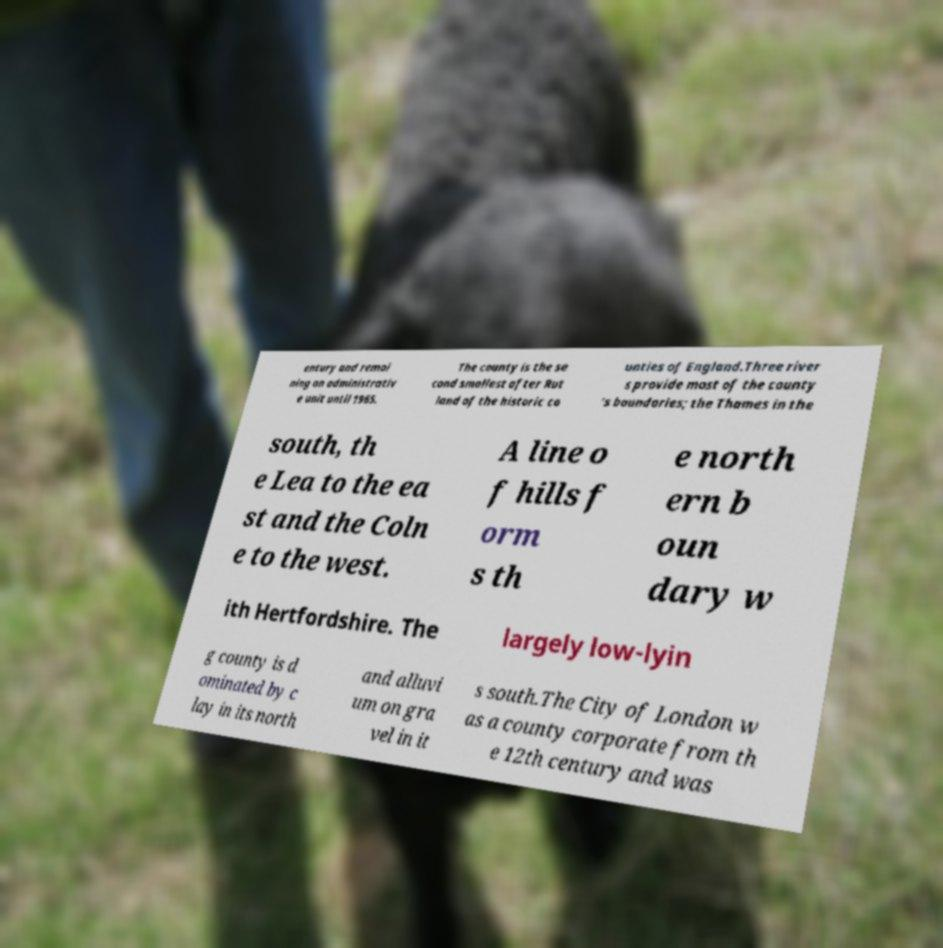I need the written content from this picture converted into text. Can you do that? entury and remai ning an administrativ e unit until 1965. The county is the se cond smallest after Rut land of the historic co unties of England.Three river s provide most of the county ’s boundaries; the Thames in the south, th e Lea to the ea st and the Coln e to the west. A line o f hills f orm s th e north ern b oun dary w ith Hertfordshire. The largely low-lyin g county is d ominated by c lay in its north and alluvi um on gra vel in it s south.The City of London w as a county corporate from th e 12th century and was 